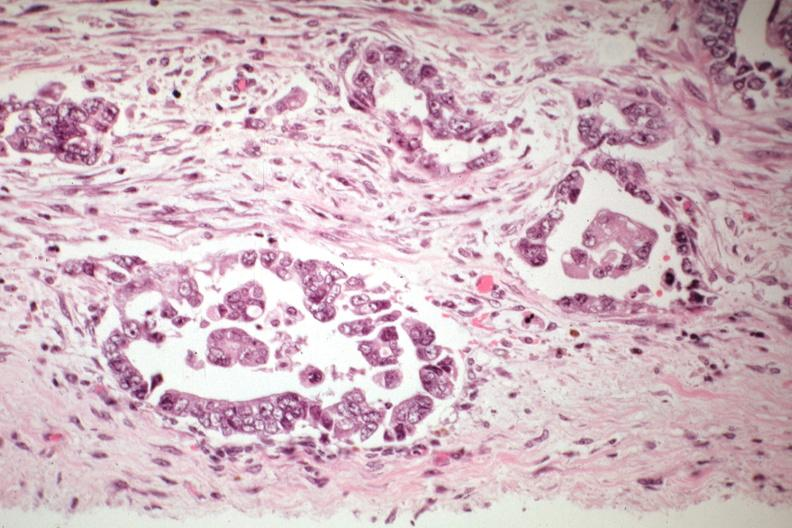where is this from?
Answer the question using a single word or phrase. Female reproductive system 